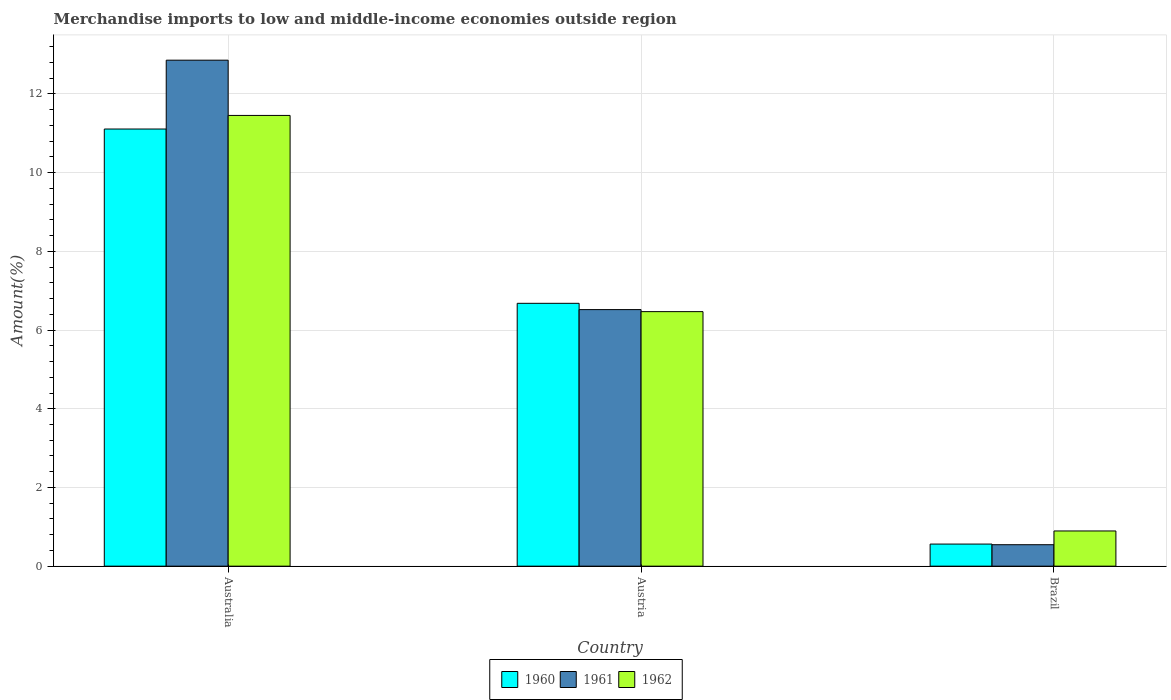How many different coloured bars are there?
Make the answer very short. 3. Are the number of bars per tick equal to the number of legend labels?
Your answer should be very brief. Yes. Are the number of bars on each tick of the X-axis equal?
Make the answer very short. Yes. How many bars are there on the 2nd tick from the left?
Provide a short and direct response. 3. In how many cases, is the number of bars for a given country not equal to the number of legend labels?
Keep it short and to the point. 0. What is the percentage of amount earned from merchandise imports in 1962 in Austria?
Provide a short and direct response. 6.47. Across all countries, what is the maximum percentage of amount earned from merchandise imports in 1960?
Provide a succinct answer. 11.11. Across all countries, what is the minimum percentage of amount earned from merchandise imports in 1962?
Ensure brevity in your answer.  0.89. In which country was the percentage of amount earned from merchandise imports in 1961 maximum?
Provide a succinct answer. Australia. In which country was the percentage of amount earned from merchandise imports in 1961 minimum?
Your answer should be very brief. Brazil. What is the total percentage of amount earned from merchandise imports in 1960 in the graph?
Your answer should be compact. 18.35. What is the difference between the percentage of amount earned from merchandise imports in 1961 in Australia and that in Austria?
Your response must be concise. 6.34. What is the difference between the percentage of amount earned from merchandise imports in 1962 in Austria and the percentage of amount earned from merchandise imports in 1960 in Brazil?
Your answer should be very brief. 5.91. What is the average percentage of amount earned from merchandise imports in 1961 per country?
Provide a short and direct response. 6.64. What is the difference between the percentage of amount earned from merchandise imports of/in 1960 and percentage of amount earned from merchandise imports of/in 1962 in Australia?
Provide a short and direct response. -0.35. In how many countries, is the percentage of amount earned from merchandise imports in 1961 greater than 6.8 %?
Provide a succinct answer. 1. What is the ratio of the percentage of amount earned from merchandise imports in 1961 in Austria to that in Brazil?
Provide a succinct answer. 11.95. Is the percentage of amount earned from merchandise imports in 1962 in Australia less than that in Brazil?
Keep it short and to the point. No. What is the difference between the highest and the second highest percentage of amount earned from merchandise imports in 1961?
Your answer should be compact. -12.31. What is the difference between the highest and the lowest percentage of amount earned from merchandise imports in 1960?
Your answer should be very brief. 10.55. Is the sum of the percentage of amount earned from merchandise imports in 1960 in Austria and Brazil greater than the maximum percentage of amount earned from merchandise imports in 1962 across all countries?
Your answer should be compact. No. What does the 2nd bar from the right in Austria represents?
Your response must be concise. 1961. How many bars are there?
Offer a very short reply. 9. Are all the bars in the graph horizontal?
Offer a terse response. No. Does the graph contain any zero values?
Make the answer very short. No. Does the graph contain grids?
Provide a succinct answer. Yes. Where does the legend appear in the graph?
Ensure brevity in your answer.  Bottom center. How are the legend labels stacked?
Provide a short and direct response. Horizontal. What is the title of the graph?
Offer a terse response. Merchandise imports to low and middle-income economies outside region. What is the label or title of the Y-axis?
Keep it short and to the point. Amount(%). What is the Amount(%) in 1960 in Australia?
Make the answer very short. 11.11. What is the Amount(%) of 1961 in Australia?
Your answer should be compact. 12.86. What is the Amount(%) in 1962 in Australia?
Offer a very short reply. 11.45. What is the Amount(%) of 1960 in Austria?
Provide a short and direct response. 6.68. What is the Amount(%) in 1961 in Austria?
Your answer should be very brief. 6.52. What is the Amount(%) in 1962 in Austria?
Offer a very short reply. 6.47. What is the Amount(%) of 1960 in Brazil?
Make the answer very short. 0.56. What is the Amount(%) in 1961 in Brazil?
Give a very brief answer. 0.55. What is the Amount(%) in 1962 in Brazil?
Provide a succinct answer. 0.89. Across all countries, what is the maximum Amount(%) of 1960?
Provide a short and direct response. 11.11. Across all countries, what is the maximum Amount(%) in 1961?
Offer a terse response. 12.86. Across all countries, what is the maximum Amount(%) of 1962?
Provide a succinct answer. 11.45. Across all countries, what is the minimum Amount(%) of 1960?
Make the answer very short. 0.56. Across all countries, what is the minimum Amount(%) in 1961?
Offer a terse response. 0.55. Across all countries, what is the minimum Amount(%) in 1962?
Your response must be concise. 0.89. What is the total Amount(%) in 1960 in the graph?
Offer a terse response. 18.35. What is the total Amount(%) in 1961 in the graph?
Your answer should be compact. 19.92. What is the total Amount(%) in 1962 in the graph?
Your response must be concise. 18.82. What is the difference between the Amount(%) in 1960 in Australia and that in Austria?
Provide a succinct answer. 4.43. What is the difference between the Amount(%) in 1961 in Australia and that in Austria?
Keep it short and to the point. 6.34. What is the difference between the Amount(%) of 1962 in Australia and that in Austria?
Give a very brief answer. 4.99. What is the difference between the Amount(%) of 1960 in Australia and that in Brazil?
Ensure brevity in your answer.  10.55. What is the difference between the Amount(%) of 1961 in Australia and that in Brazil?
Your response must be concise. 12.31. What is the difference between the Amount(%) of 1962 in Australia and that in Brazil?
Offer a terse response. 10.56. What is the difference between the Amount(%) in 1960 in Austria and that in Brazil?
Provide a succinct answer. 6.12. What is the difference between the Amount(%) in 1961 in Austria and that in Brazil?
Your response must be concise. 5.97. What is the difference between the Amount(%) of 1962 in Austria and that in Brazil?
Provide a succinct answer. 5.57. What is the difference between the Amount(%) in 1960 in Australia and the Amount(%) in 1961 in Austria?
Give a very brief answer. 4.59. What is the difference between the Amount(%) in 1960 in Australia and the Amount(%) in 1962 in Austria?
Offer a very short reply. 4.64. What is the difference between the Amount(%) of 1961 in Australia and the Amount(%) of 1962 in Austria?
Give a very brief answer. 6.39. What is the difference between the Amount(%) of 1960 in Australia and the Amount(%) of 1961 in Brazil?
Offer a very short reply. 10.56. What is the difference between the Amount(%) in 1960 in Australia and the Amount(%) in 1962 in Brazil?
Give a very brief answer. 10.21. What is the difference between the Amount(%) of 1961 in Australia and the Amount(%) of 1962 in Brazil?
Provide a succinct answer. 11.96. What is the difference between the Amount(%) of 1960 in Austria and the Amount(%) of 1961 in Brazil?
Your response must be concise. 6.13. What is the difference between the Amount(%) in 1960 in Austria and the Amount(%) in 1962 in Brazil?
Your response must be concise. 5.78. What is the difference between the Amount(%) in 1961 in Austria and the Amount(%) in 1962 in Brazil?
Your response must be concise. 5.63. What is the average Amount(%) of 1960 per country?
Give a very brief answer. 6.12. What is the average Amount(%) of 1961 per country?
Your answer should be very brief. 6.64. What is the average Amount(%) of 1962 per country?
Offer a terse response. 6.27. What is the difference between the Amount(%) in 1960 and Amount(%) in 1961 in Australia?
Offer a very short reply. -1.75. What is the difference between the Amount(%) of 1960 and Amount(%) of 1962 in Australia?
Keep it short and to the point. -0.35. What is the difference between the Amount(%) of 1961 and Amount(%) of 1962 in Australia?
Offer a terse response. 1.4. What is the difference between the Amount(%) in 1960 and Amount(%) in 1961 in Austria?
Offer a very short reply. 0.16. What is the difference between the Amount(%) in 1960 and Amount(%) in 1962 in Austria?
Make the answer very short. 0.21. What is the difference between the Amount(%) in 1961 and Amount(%) in 1962 in Austria?
Ensure brevity in your answer.  0.05. What is the difference between the Amount(%) of 1960 and Amount(%) of 1961 in Brazil?
Give a very brief answer. 0.02. What is the difference between the Amount(%) of 1960 and Amount(%) of 1962 in Brazil?
Give a very brief answer. -0.33. What is the difference between the Amount(%) of 1961 and Amount(%) of 1962 in Brazil?
Your answer should be compact. -0.35. What is the ratio of the Amount(%) of 1960 in Australia to that in Austria?
Offer a very short reply. 1.66. What is the ratio of the Amount(%) in 1961 in Australia to that in Austria?
Keep it short and to the point. 1.97. What is the ratio of the Amount(%) of 1962 in Australia to that in Austria?
Ensure brevity in your answer.  1.77. What is the ratio of the Amount(%) in 1960 in Australia to that in Brazil?
Your response must be concise. 19.78. What is the ratio of the Amount(%) in 1961 in Australia to that in Brazil?
Your answer should be very brief. 23.58. What is the ratio of the Amount(%) of 1962 in Australia to that in Brazil?
Offer a terse response. 12.8. What is the ratio of the Amount(%) of 1960 in Austria to that in Brazil?
Offer a terse response. 11.9. What is the ratio of the Amount(%) in 1961 in Austria to that in Brazil?
Give a very brief answer. 11.95. What is the ratio of the Amount(%) of 1962 in Austria to that in Brazil?
Your answer should be compact. 7.23. What is the difference between the highest and the second highest Amount(%) of 1960?
Provide a short and direct response. 4.43. What is the difference between the highest and the second highest Amount(%) of 1961?
Your answer should be compact. 6.34. What is the difference between the highest and the second highest Amount(%) in 1962?
Provide a succinct answer. 4.99. What is the difference between the highest and the lowest Amount(%) in 1960?
Provide a succinct answer. 10.55. What is the difference between the highest and the lowest Amount(%) in 1961?
Offer a very short reply. 12.31. What is the difference between the highest and the lowest Amount(%) of 1962?
Offer a terse response. 10.56. 